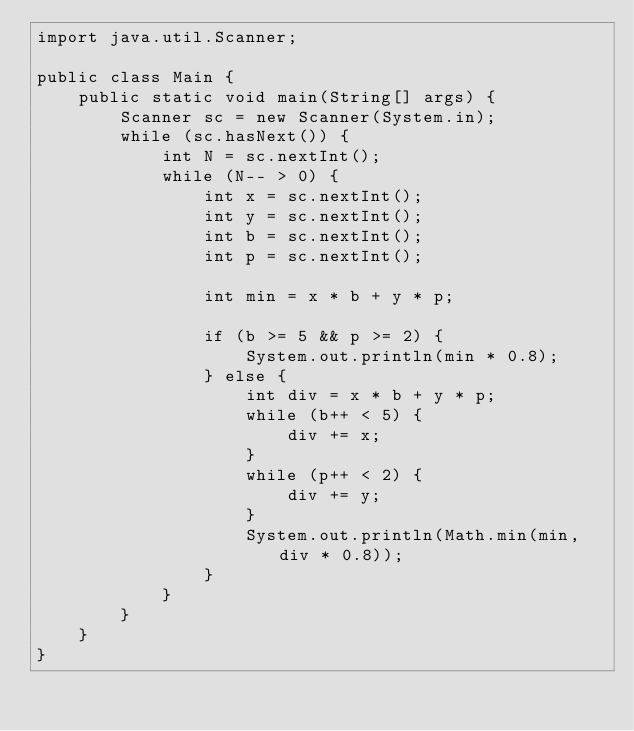Convert code to text. <code><loc_0><loc_0><loc_500><loc_500><_Java_>import java.util.Scanner;

public class Main {
	public static void main(String[] args) {
		Scanner sc = new Scanner(System.in);
		while (sc.hasNext()) {
			int N = sc.nextInt();
			while (N-- > 0) {
				int x = sc.nextInt();
				int y = sc.nextInt();
				int b = sc.nextInt();
				int p = sc.nextInt();

				int min = x * b + y * p;

				if (b >= 5 && p >= 2) {
					System.out.println(min * 0.8);
				} else {
					int div = x * b + y * p;
					while (b++ < 5) {
						div += x;
					}
					while (p++ < 2) {
						div += y;
					}
					System.out.println(Math.min(min, div * 0.8));
				}
			}
		}
	}
}</code> 